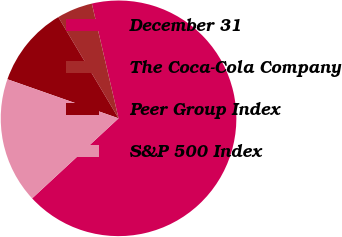<chart> <loc_0><loc_0><loc_500><loc_500><pie_chart><fcel>December 31<fcel>The Coca-Cola Company<fcel>Peer Group Index<fcel>S&P 500 Index<nl><fcel>66.75%<fcel>4.9%<fcel>11.08%<fcel>17.27%<nl></chart> 